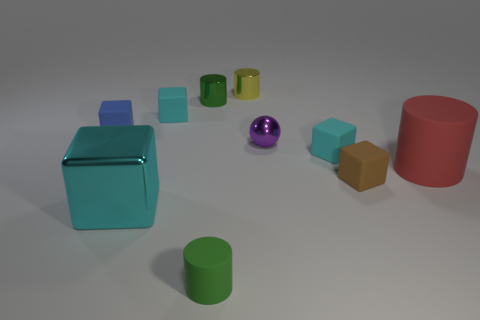Subtract all cyan blocks. How many were subtracted if there are1cyan blocks left? 2 Subtract all small cylinders. How many cylinders are left? 1 Subtract all green blocks. How many green cylinders are left? 2 Subtract all red cylinders. How many cylinders are left? 3 Subtract all balls. How many objects are left? 9 Subtract 2 blocks. How many blocks are left? 3 Add 9 spheres. How many spheres are left? 10 Add 2 yellow shiny objects. How many yellow shiny objects exist? 3 Subtract 0 cyan cylinders. How many objects are left? 10 Subtract all red spheres. Subtract all gray cylinders. How many spheres are left? 1 